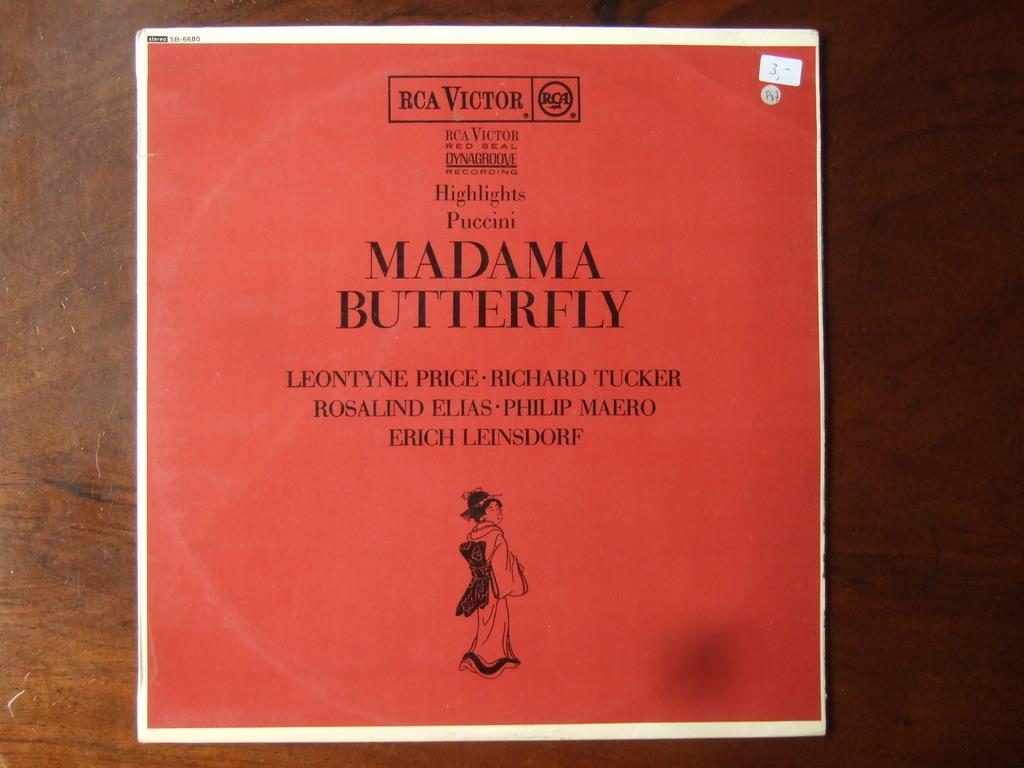What is the title of the book?
Provide a short and direct response. Madama butterfly. 